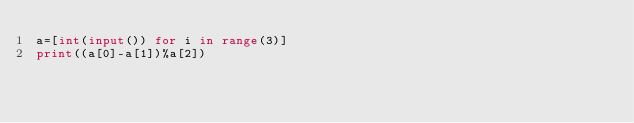Convert code to text. <code><loc_0><loc_0><loc_500><loc_500><_Python_>a=[int(input()) for i in range(3)]
print((a[0]-a[1])%a[2])</code> 